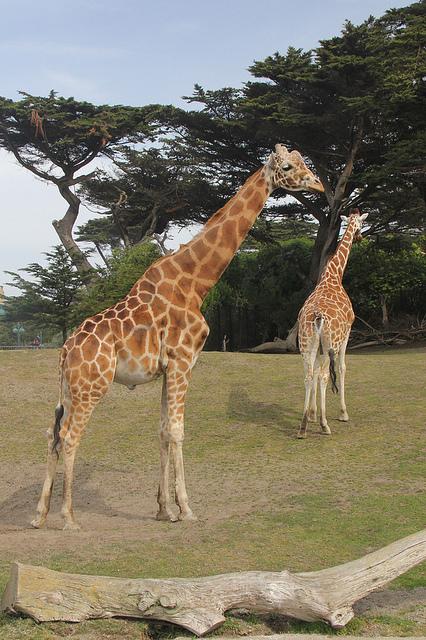Are the animals wild?
Write a very short answer. Yes. Are the animals in a zoo?
Give a very brief answer. Yes. How many animals are here?
Keep it brief. 2. 